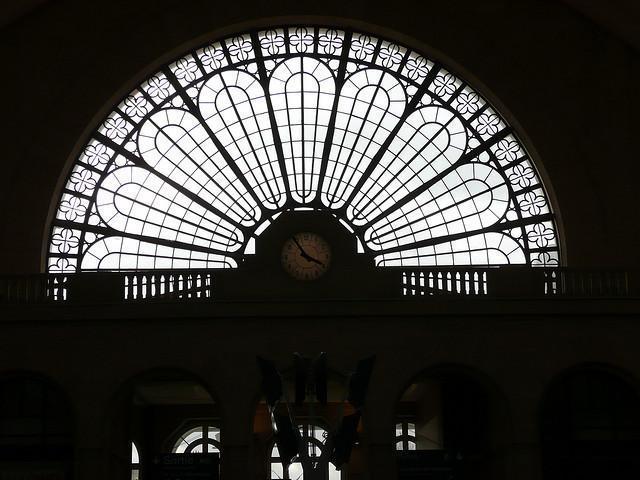How many clocks are on the building?
Give a very brief answer. 1. 